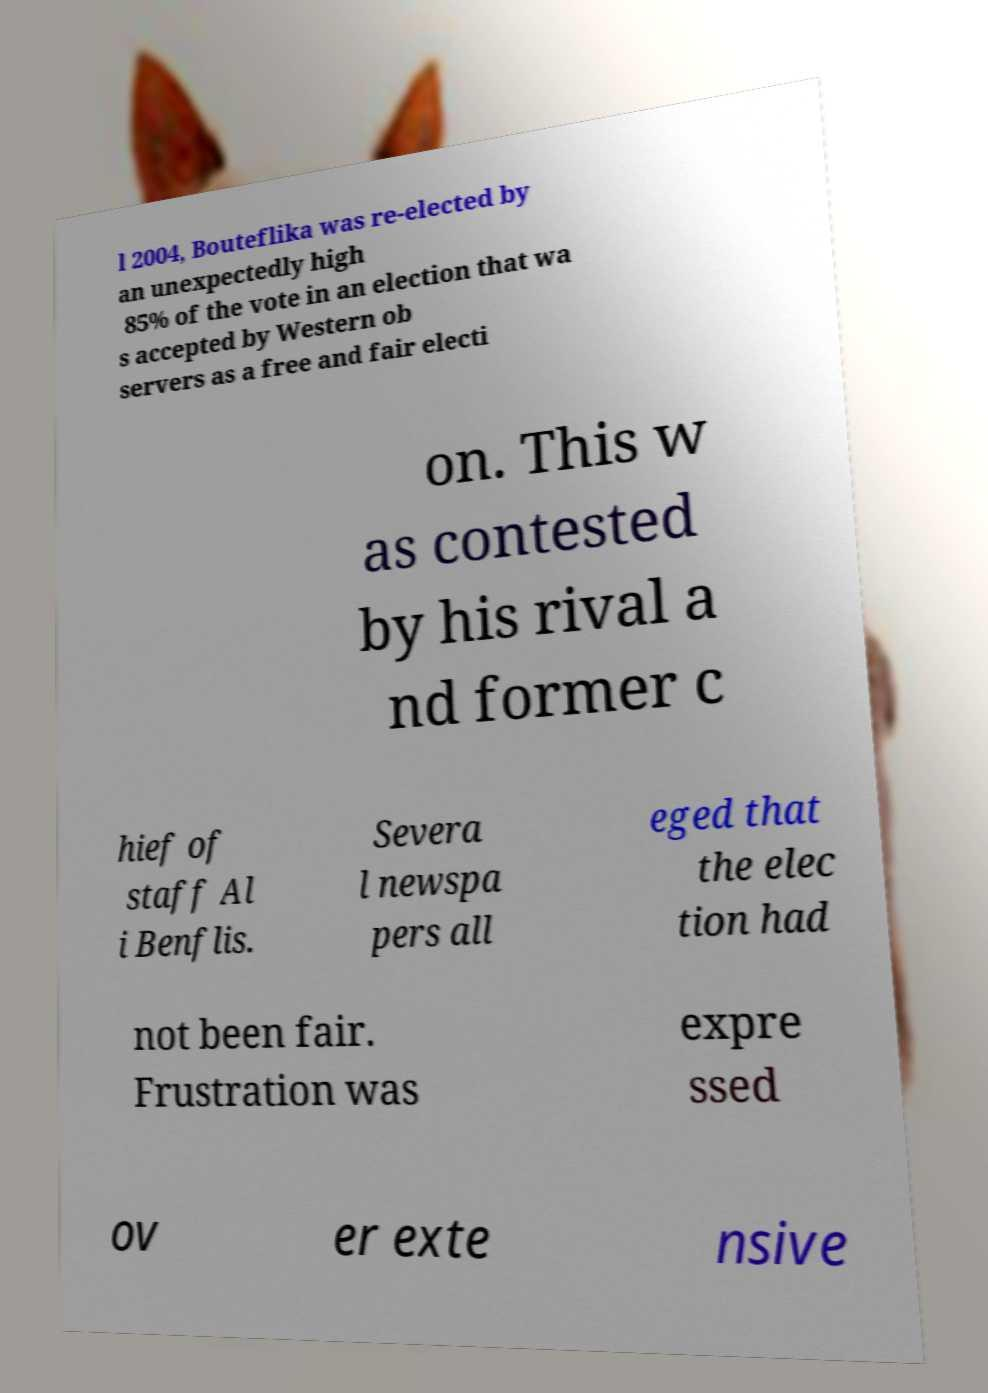For documentation purposes, I need the text within this image transcribed. Could you provide that? l 2004, Bouteflika was re-elected by an unexpectedly high 85% of the vote in an election that wa s accepted by Western ob servers as a free and fair electi on. This w as contested by his rival a nd former c hief of staff Al i Benflis. Severa l newspa pers all eged that the elec tion had not been fair. Frustration was expre ssed ov er exte nsive 